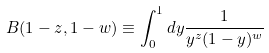<formula> <loc_0><loc_0><loc_500><loc_500>B ( 1 - z , 1 - w ) \equiv \int _ { 0 } ^ { 1 } d y \frac { 1 } { y ^ { z } ( 1 - y ) ^ { w } }</formula> 